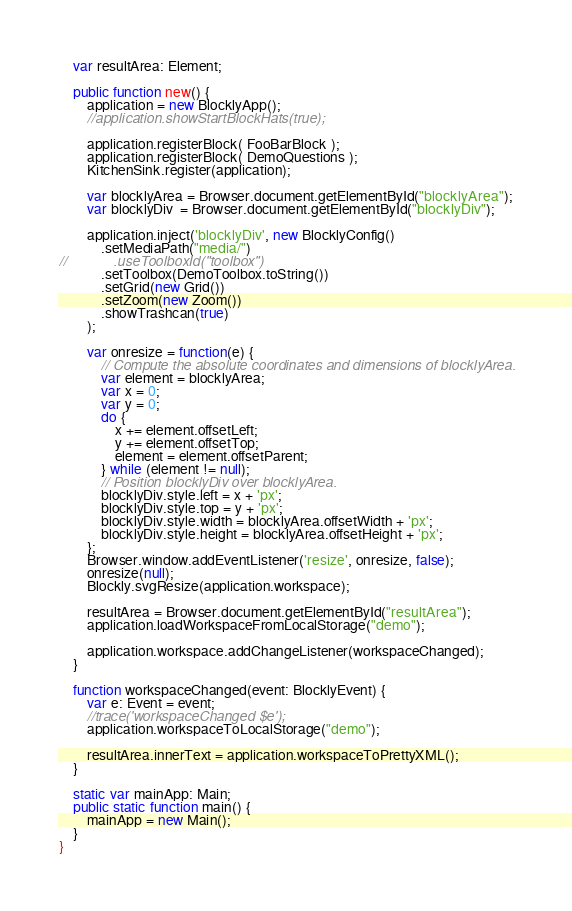<code> <loc_0><loc_0><loc_500><loc_500><_Haxe_>    var resultArea: Element;

    public function new() {
        application = new BlocklyApp();
        //application.showStartBlockHats(true);

        application.registerBlock( FooBarBlock );
        application.registerBlock( DemoQuestions );
        KitchenSink.register(application);

        var blocklyArea = Browser.document.getElementById("blocklyArea");
        var blocklyDiv  = Browser.document.getElementById("blocklyDiv");

        application.inject('blocklyDiv', new BlocklyConfig()
            .setMediaPath("media/")
//            .useToolboxId("toolbox")
            .setToolbox(DemoToolbox.toString())
            .setGrid(new Grid())
            .setZoom(new Zoom())
            .showTrashcan(true)
        );

        var onresize = function(e) {
            // Compute the absolute coordinates and dimensions of blocklyArea.
            var element = blocklyArea;
            var x = 0;
            var y = 0;
            do {
                x += element.offsetLeft;
                y += element.offsetTop;
                element = element.offsetParent;
            } while (element != null);
            // Position blocklyDiv over blocklyArea.
            blocklyDiv.style.left = x + 'px';
            blocklyDiv.style.top = y + 'px';
            blocklyDiv.style.width = blocklyArea.offsetWidth + 'px';
            blocklyDiv.style.height = blocklyArea.offsetHeight + 'px';
        };
        Browser.window.addEventListener('resize', onresize, false);
        onresize(null);
        Blockly.svgResize(application.workspace);

        resultArea = Browser.document.getElementById("resultArea");
        application.loadWorkspaceFromLocalStorage("demo");

        application.workspace.addChangeListener(workspaceChanged);
    }

    function workspaceChanged(event: BlocklyEvent) {
        var e: Event = event;
        //trace('workspaceChanged $e');
        application.workspaceToLocalStorage("demo");

        resultArea.innerText = application.workspaceToPrettyXML();
    }

    static var mainApp: Main;
    public static function main() {
        mainApp = new Main();
    }
}</code> 